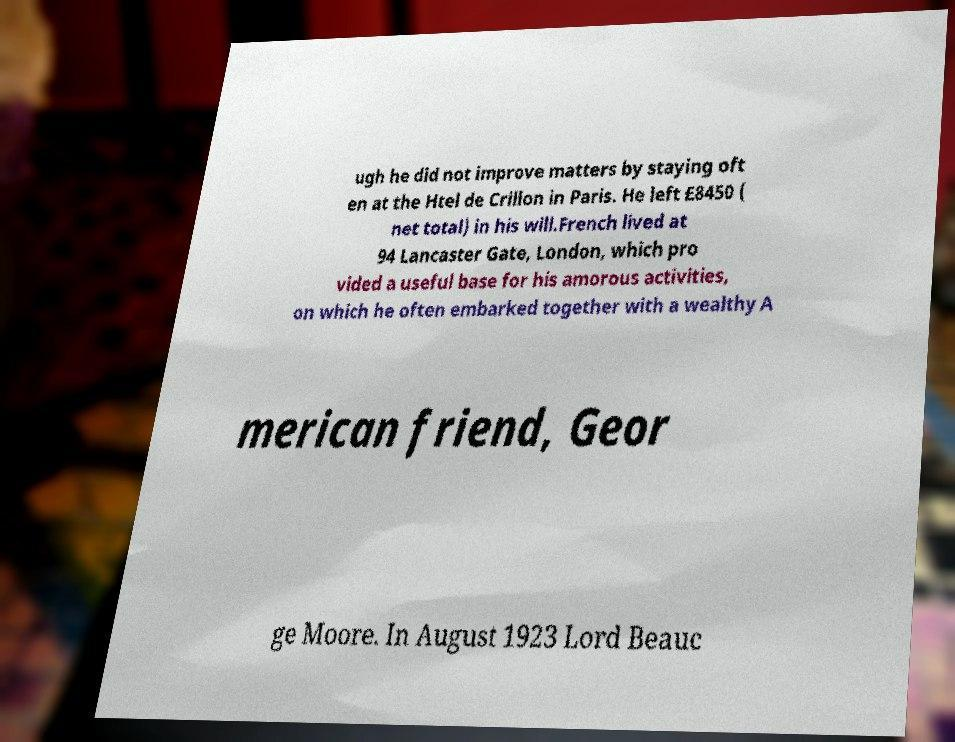What messages or text are displayed in this image? I need them in a readable, typed format. ugh he did not improve matters by staying oft en at the Htel de Crillon in Paris. He left £8450 ( net total) in his will.French lived at 94 Lancaster Gate, London, which pro vided a useful base for his amorous activities, on which he often embarked together with a wealthy A merican friend, Geor ge Moore. In August 1923 Lord Beauc 